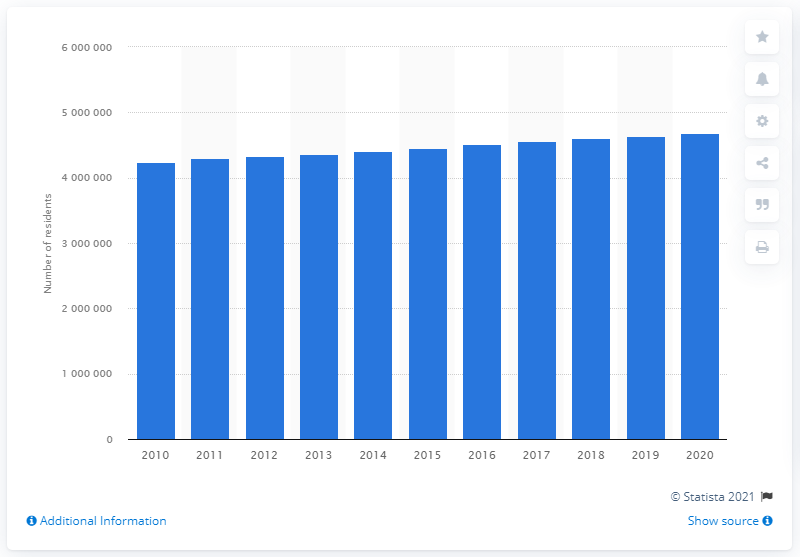Point out several critical features in this image. In 2020, the population of the Riverside-San Bernardino-Ontario metropolitan area was approximately 4,642,848 people. The population of the Riverside-San Bernardino-Ontario metropolitan area in the previous year was approximately 4608848. 